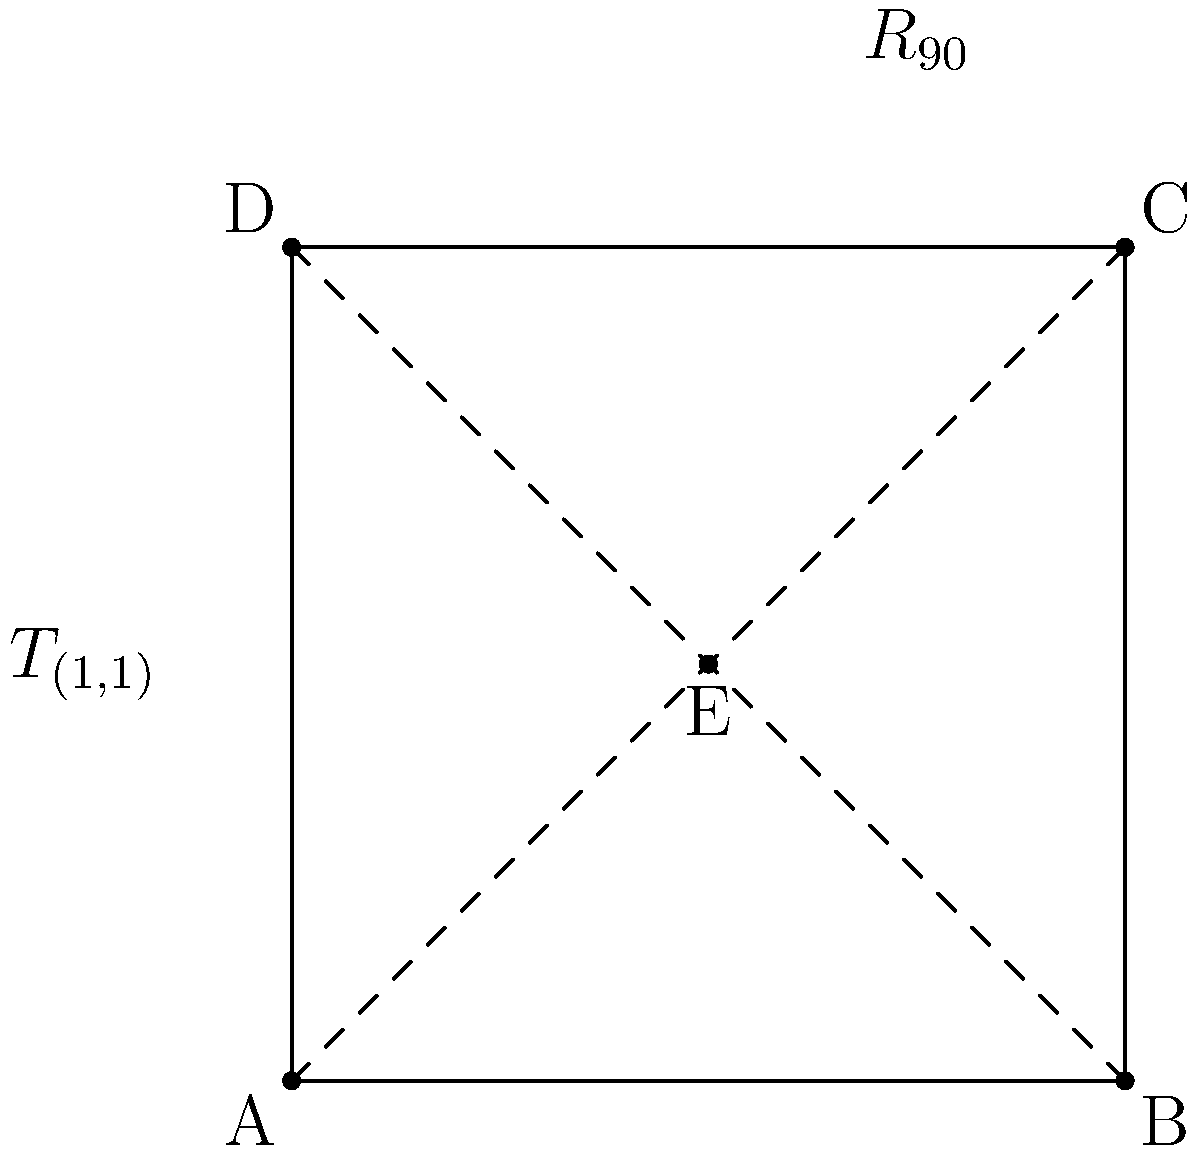In a floor exercise routine diagram, a gymnast performs a 90-degree rotation clockwise around the center (E), followed by a translation of (1,1) units. If point A represents the starting position, what is the final position of A after these transformations? Express your answer as coordinates. Let's approach this step-by-step:

1) First, we need to perform a 90-degree clockwise rotation around point E (1,1):
   - The initial position of A is (0,0)
   - To rotate around E, we first translate A by (-1,-1), rotate, then translate back
   - After translation: (0,0) → (-1,-1)
   - 90-degree clockwise rotation: (-1,-1) → (1,-1)
   - Translating back: (1,-1) → (2,0)
   
2) Now, we apply the translation of (1,1):
   - (2,0) → (3,1)

Therefore, the final position of A after both transformations is (3,1).

This problem demonstrates the importance of sequence in transformations, much like the sequence of moves in a gymnastics routine. The resilience required in gymnastics is mirrored in the persistent step-by-step approach needed to solve such problems.
Answer: (3,1) 